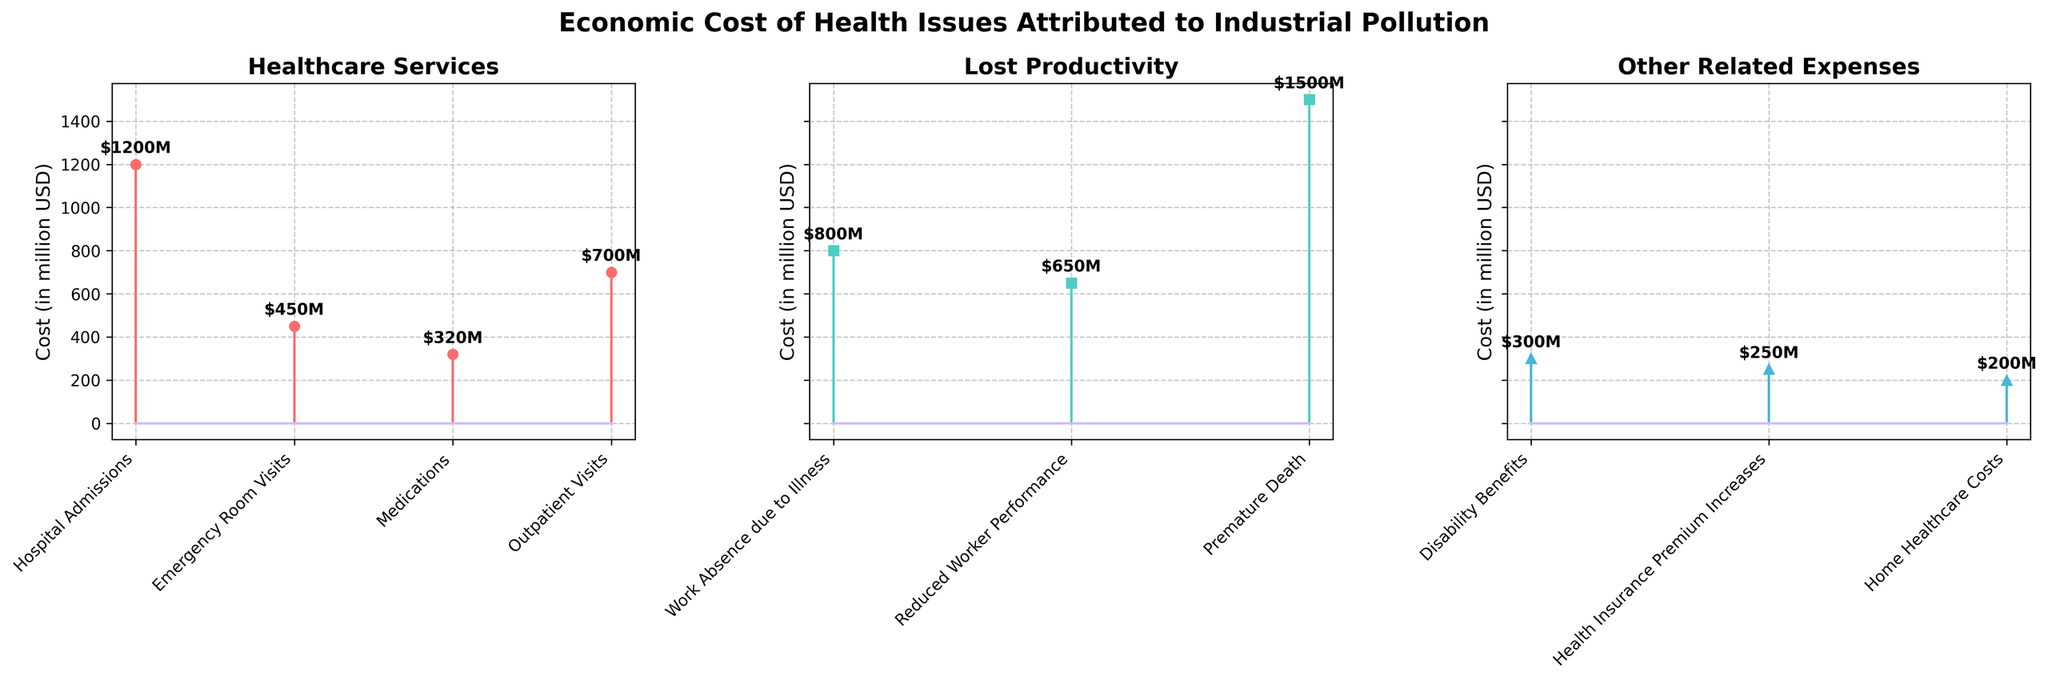What is the title of the figure? The title is typically found at the top of the figure and summarizes the main topic of the chart.
Answer: Economic Cost of Health Issues Attributed to Industrial Pollution How many subplots are there in the figure? The figure consists of three separate sections, each representing a different category of costs.
Answer: 3 Which category has the highest single cost, and what is that cost? By comparing the peaks in each subplot, we look for the highest value. The "Premature Death" cost in the "Lost Productivity" category is the highest.
Answer: Lost Productivity, $1500 million What are the types of costs included in the Healthcare Services category? The x-axis labels of the Healthcare Services subplot list the types of costs.
Answer: Hospital Admissions, Emergency Room Visits, Medications, Outpatient Visits Sum up the total cost for Healthcare Services. Add the costs for all types under Healthcare Services: 1200 + 450 + 320 + 700. The total is 2670 million USD.
Answer: $2670 million Which type of cost in the Other Related Expenses category has the smallest economic impact? By examining the y-values in the Other Related Expenses subplot, the smallest value is identified as Home Healthcare Costs.
Answer: Home Healthcare Costs Which category has the least overall economic cost, and what is the total for that category? Sum the costs for each category and compare the totals: 
Healthcare Services: 2670,
Lost Productivity: 2950,
Other Related Expenses: 750. 
Other Related Expenses has the least total cost.
Answer: Other Related Expenses, $750 million How does the cost of Work Absence due to Illness compare to Reduced Worker Performance? Compare the y-values of both types in the Lost Productivity subplot. Work Absence due to Illness is 800 million USD, which is higher than Reduced Worker Performance (650 million USD).
Answer: Work Absence due to Illness is higher What is the average cost of the items in the Lost Productivity category? Sum the costs in Lost Productivity (800 + 650 + 1500) = 2950. Then, divide by the number of items (3). The average is 2950/3 ≈ 983.33 million USD.
Answer: $983.33 million Are there more data points in Healthcare Services or Other Related Expenses? Count the number of cost types in each category subplot. Healthcare Services has 4, and Other Related Expenses has 3.
Answer: Healthcare Services 